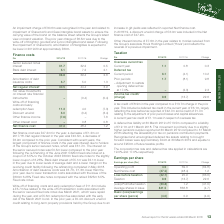According to Premier Foods Plc's financial document, What was the tax credit amount in the current year? According to the financial document, £8.9m. The relevant text states: "A tax credit of £8.9m in the year compared to a £13.7m charge in the prior year. This included a deferred tax credit in th..." Also, What was the deferred tax liability at 30 March 2019? According to the financial document, £13.5m. The relevant text states: "A deferred tax liability at 30 March 2019 of £13.5m compared to a liability of £12.1m at 31 March 2018. This movement is primarily due to a slightly hig..." Also, What was the corporation tax rate? According to the financial document, 19.0%. The relevant text states: "and deferred tax rate applied in calculations are 19.0% and 17.0% respectively...." Also, can you calculate: What was the percentage change in the overseas current tax from 2017/18 to 2018/19? To answer this question, I need to perform calculations using the financial data. The calculation is: 1.1 / 0.8 - 1, which equals 37.5 (percentage). This is based on the information: "Overseas current tax Current year 1.1 0.8 0.3 Overseas current tax Current year 1.1 0.8 0.3..." The key data points involved are: 0.8, 1.1. Also, can you calculate: What was the average deferred tax for 2017/18 and 2018/19? To answer this question, I need to perform calculations using the financial data. The calculation is: (6.1 - 4.1) / 2, which equals 1 (in millions). This is based on the information: "Deferred tax Current period 6.1 (4.1) 10.2 Prior periods 1.7 (8.1) 9.8 – Adjustment to restate opening deferred tax at 17.0% – (2.3) 2.3 Deferred tax Current period 6.1 (4.1) 10.2 Prior periods 1.7 (8..." The key data points involved are: 4.1, 6.1. Also, can you calculate: What was the average income tax credit / (charge) for 2017/18 and 2018/19? To answer this question, I need to perform calculations using the financial data. The calculation is: (8.9 - 13.7) / 2, which equals -2.4 (in millions). This is based on the information: "Income tax credit/ (charge) 8.9 (13.7) 22.6 Income tax credit/ (charge) 8.9 (13.7) 22.6..." The key data points involved are: 13.7, 8.9. 